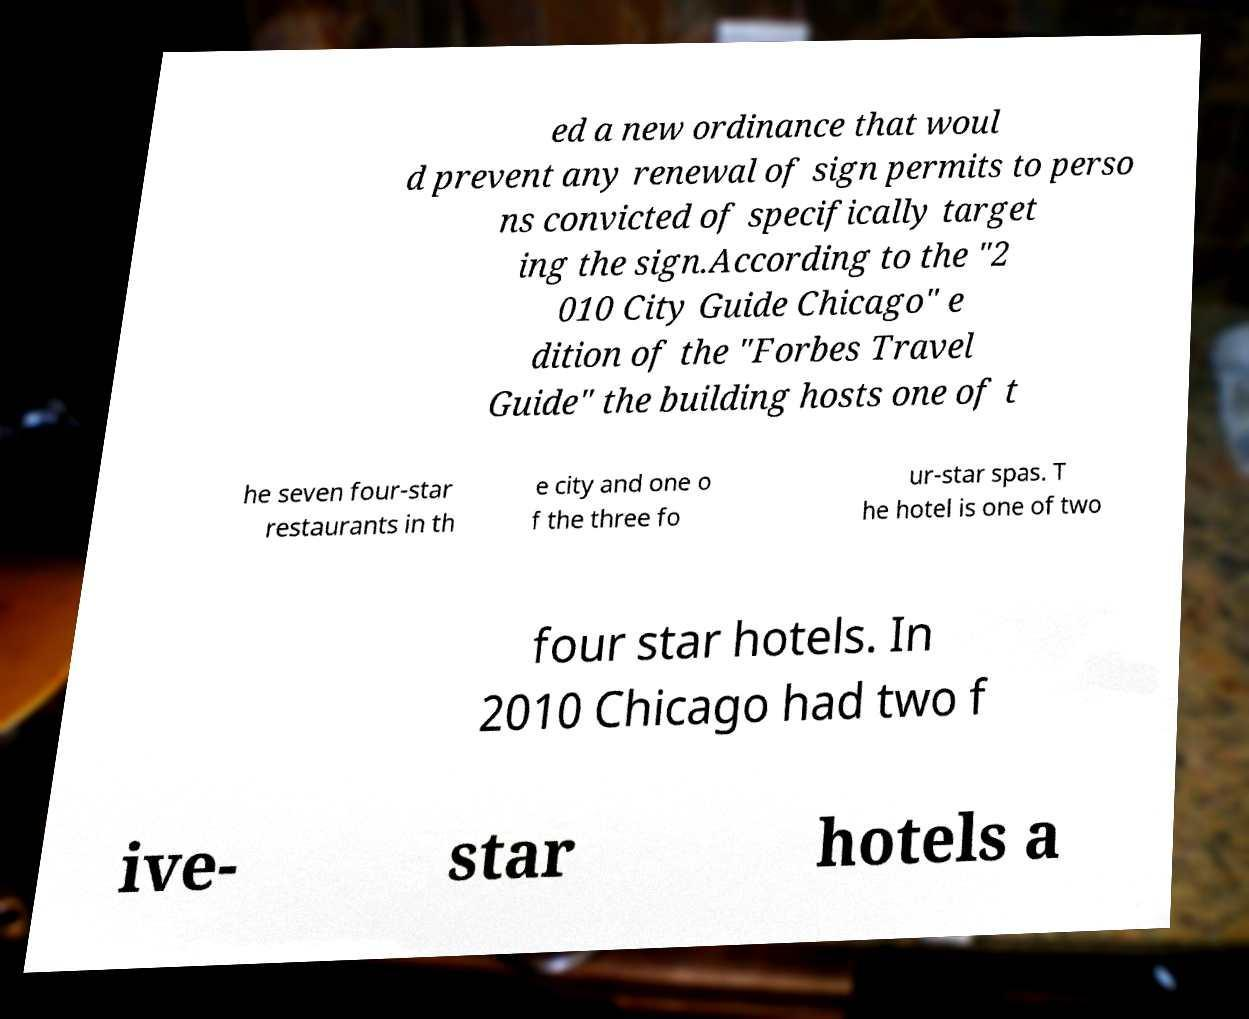Please identify and transcribe the text found in this image. ed a new ordinance that woul d prevent any renewal of sign permits to perso ns convicted of specifically target ing the sign.According to the "2 010 City Guide Chicago" e dition of the "Forbes Travel Guide" the building hosts one of t he seven four-star restaurants in th e city and one o f the three fo ur-star spas. T he hotel is one of two four star hotels. In 2010 Chicago had two f ive- star hotels a 